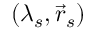<formula> <loc_0><loc_0><loc_500><loc_500>( \lambda _ { s } , \vec { r } _ { s } )</formula> 